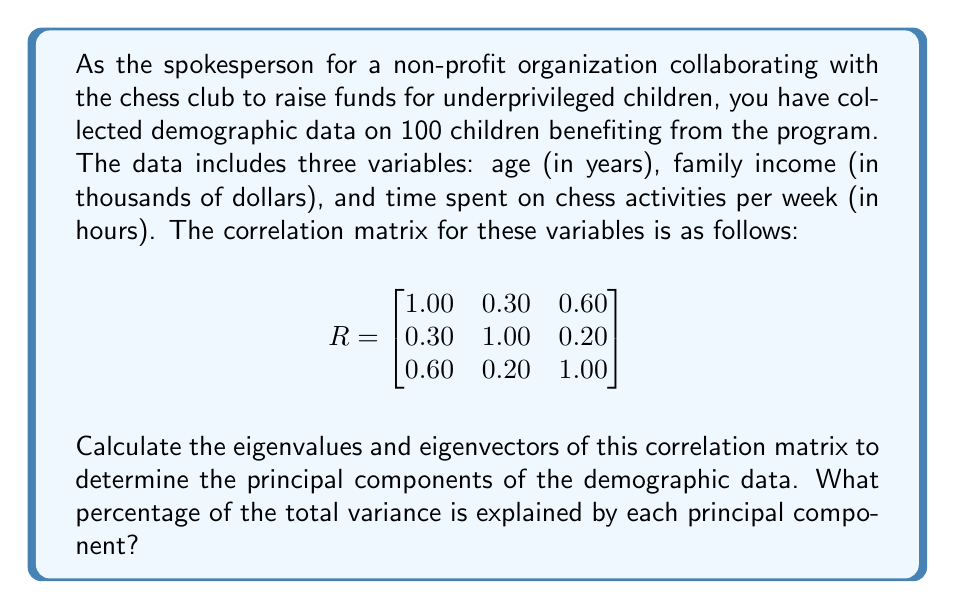Can you answer this question? To calculate the principal components, we need to find the eigenvalues and eigenvectors of the correlation matrix. Let's approach this step-by-step:

1) First, we need to solve the characteristic equation:
   $\det(R - \lambda I) = 0$

2) Expanding this determinant:
   $$\begin{vmatrix}
   1-\lambda & 0.30 & 0.60 \\
   0.30 & 1-\lambda & 0.20 \\
   0.60 & 0.20 & 1-\lambda
   \end{vmatrix} = 0$$

3) This expands to:
   $(1-\lambda)^3 + 2(0.30)(0.60)(0.20) - (1-\lambda)[(0.30)^2 + (0.60)^2 + (0.20)^2] = 0$

4) Simplifying:
   $-\lambda^3 + 3\lambda^2 - 2.59\lambda + 0.468 = 0$

5) Solving this cubic equation (using a calculator or computer algebra system) gives us the eigenvalues:
   $\lambda_1 \approx 1.8354$
   $\lambda_2 \approx 0.7866$
   $\lambda_3 \approx 0.3780$

6) To find the eigenvectors, we solve $(R - \lambda_i I)v_i = 0$ for each $\lambda_i$.

7) After normalizing, the eigenvectors are approximately:
   $v_1 = [0.6508, 0.3200, 0.6882]^T$
   $v_2 = [-0.0989, 0.9461, -0.3089]^T$
   $v_3 = [0.7530, -0.0555, -0.6557]^T$

8) The percentage of variance explained by each principal component is given by:
   $\frac{\lambda_i}{\sum \lambda_i} \times 100\%$

   For PC1: $\frac{1.8354}{3} \times 100\% \approx 61.18\%$
   For PC2: $\frac{0.7866}{3} \times 100\% \approx 26.22\%$
   For PC3: $\frac{0.3780}{3} \times 100\% \approx 12.60\%$
Answer: The principal components are:
PC1: $[0.6508, 0.3200, 0.6882]^T$, explaining 61.18% of variance
PC2: $[-0.0989, 0.9461, -0.3089]^T$, explaining 26.22% of variance
PC3: $[0.7530, -0.0555, -0.6557]^T$, explaining 12.60% of variance 